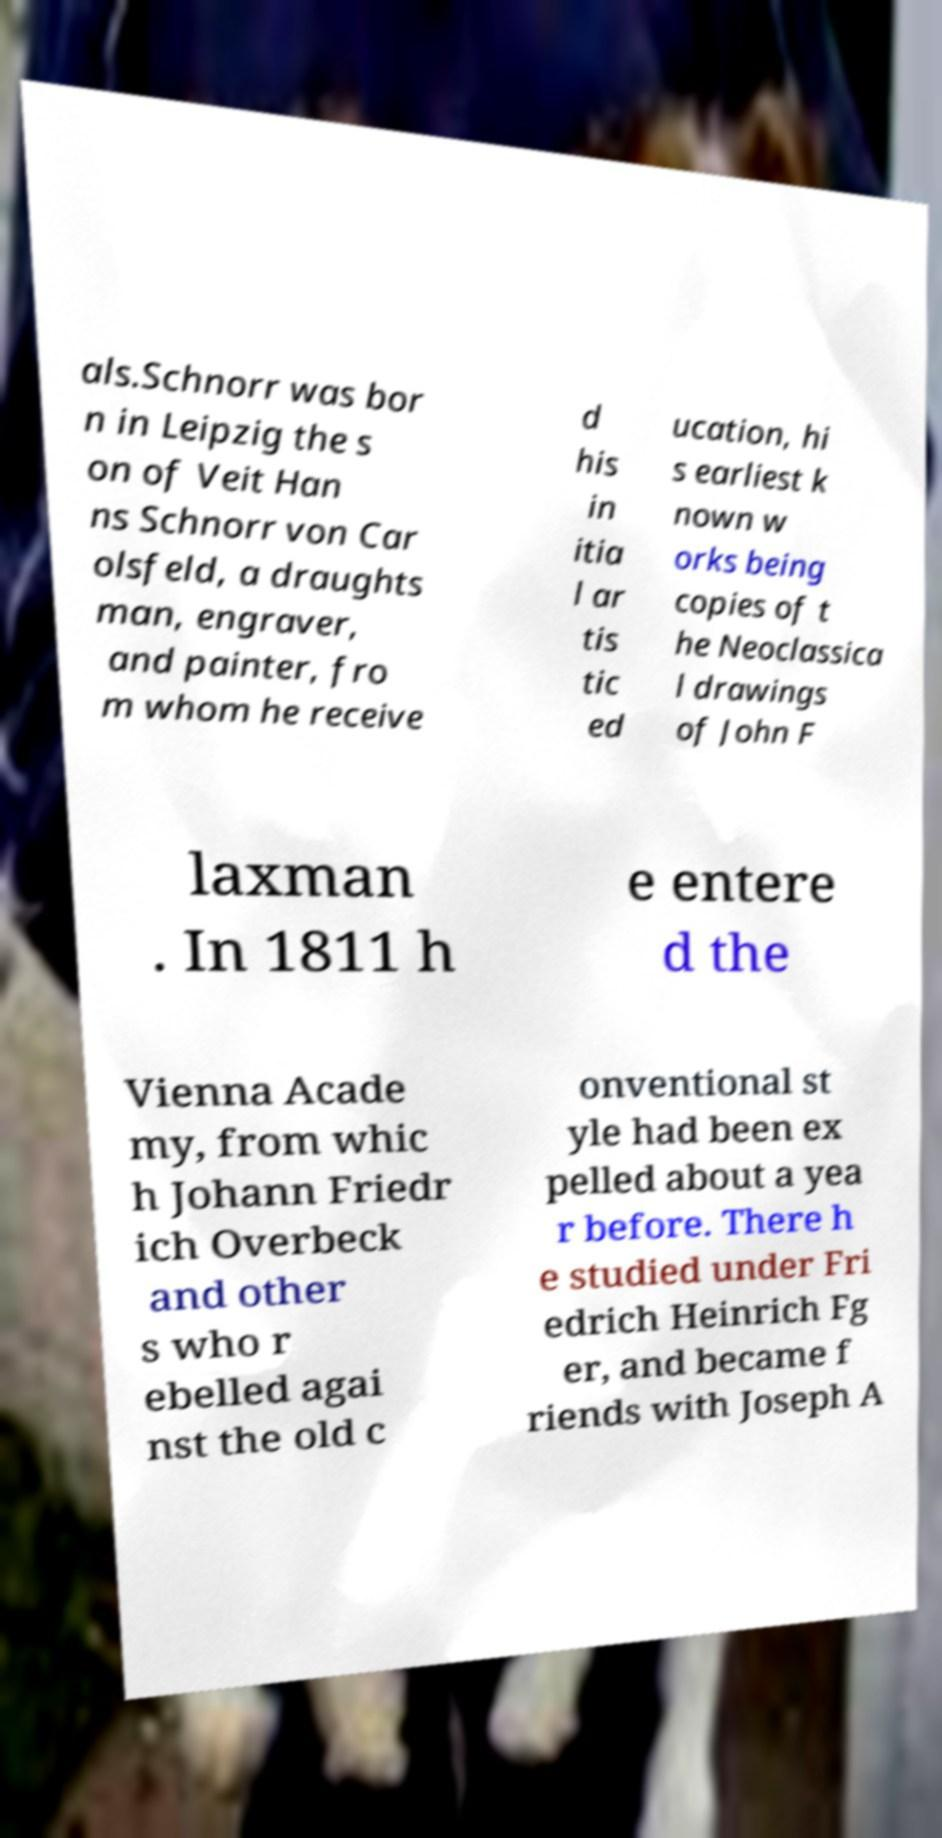Please identify and transcribe the text found in this image. als.Schnorr was bor n in Leipzig the s on of Veit Han ns Schnorr von Car olsfeld, a draughts man, engraver, and painter, fro m whom he receive d his in itia l ar tis tic ed ucation, hi s earliest k nown w orks being copies of t he Neoclassica l drawings of John F laxman . In 1811 h e entere d the Vienna Acade my, from whic h Johann Friedr ich Overbeck and other s who r ebelled agai nst the old c onventional st yle had been ex pelled about a yea r before. There h e studied under Fri edrich Heinrich Fg er, and became f riends with Joseph A 